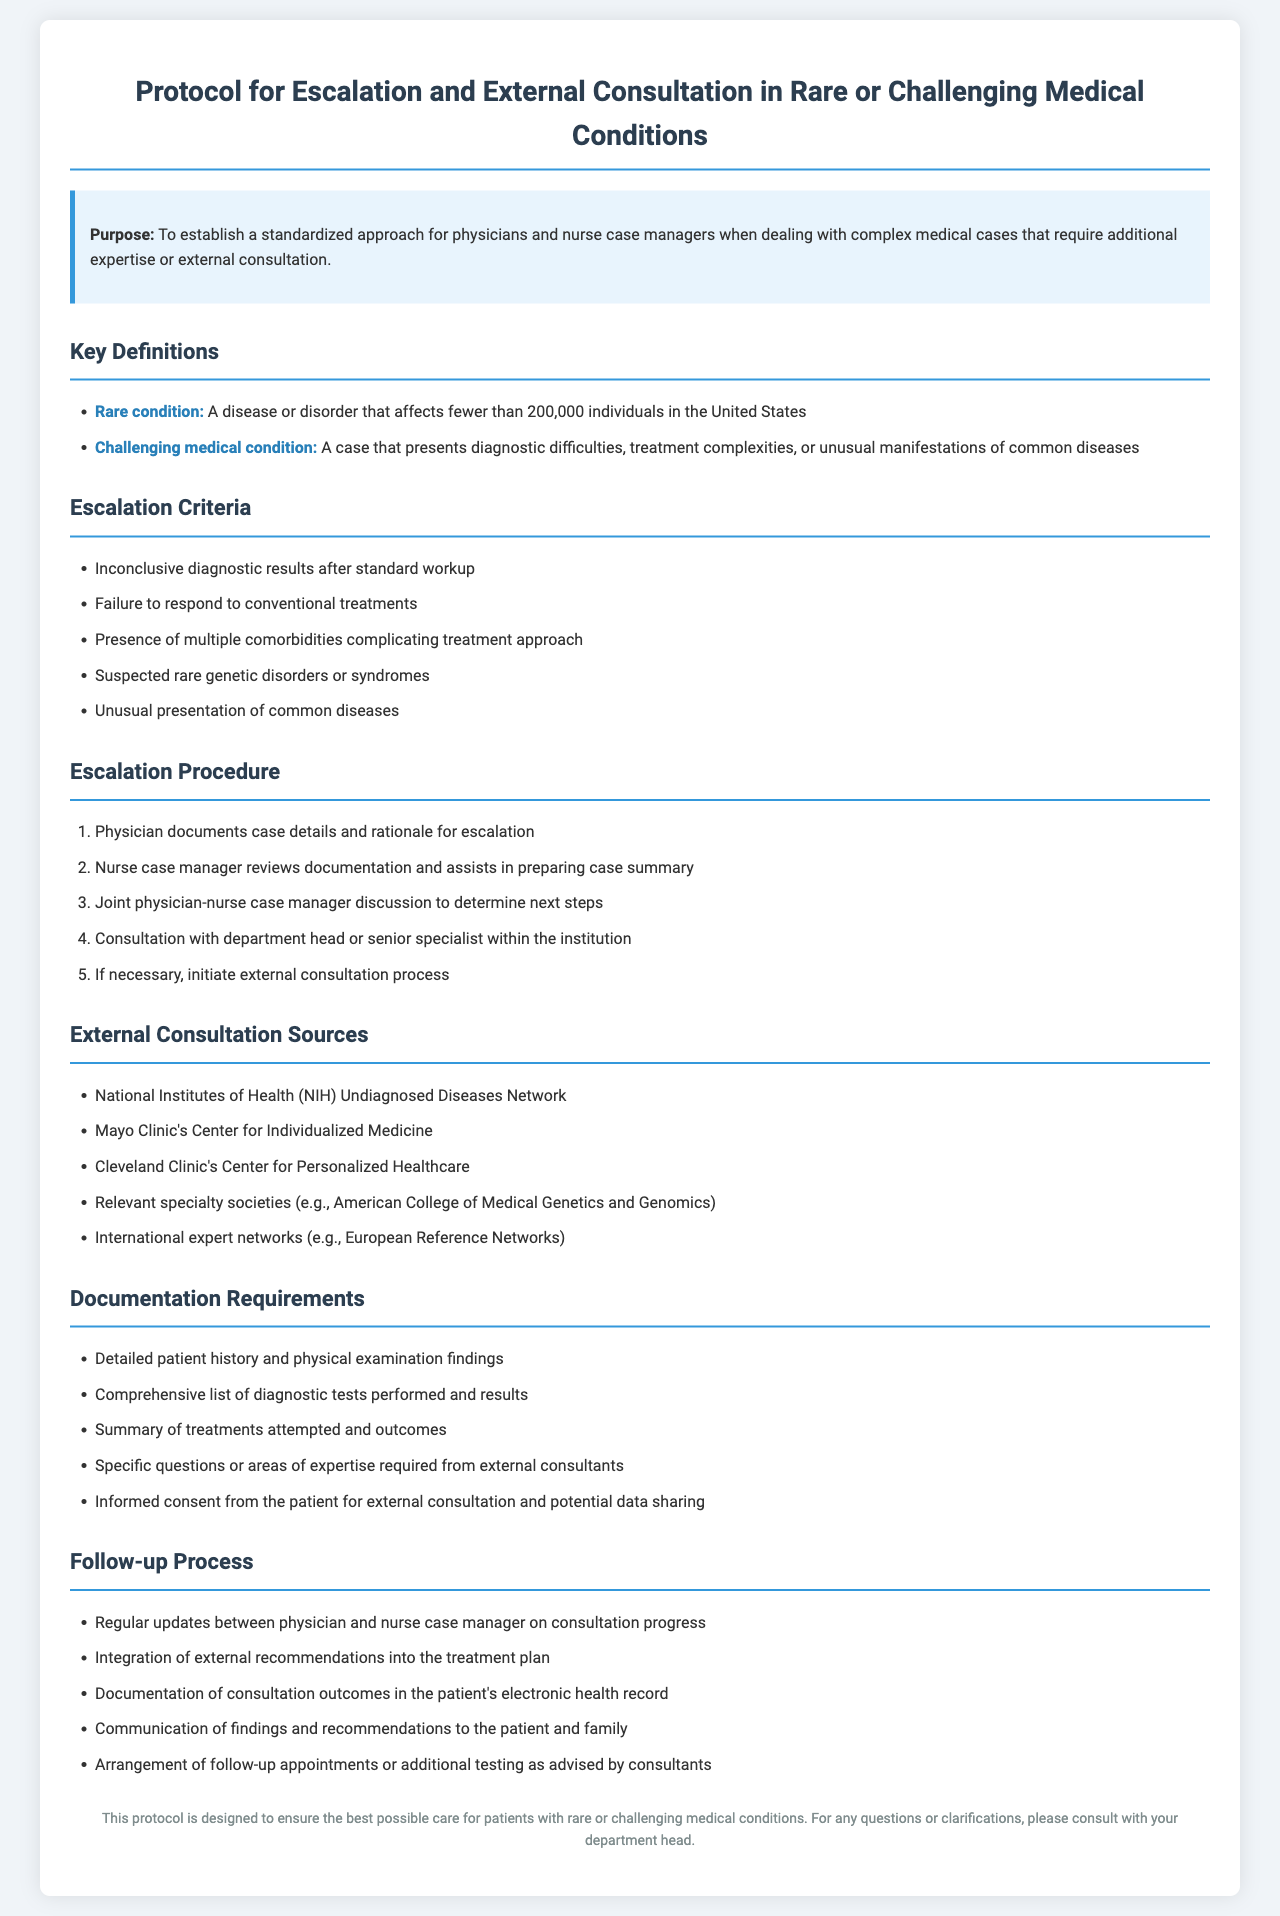What is the purpose of the protocol? The purpose of the protocol is to establish a standardized approach for physicians and nurse case managers when dealing with complex medical cases that require additional expertise or external consultation.
Answer: To establish a standardized approach What constitutes a rare condition? A rare condition is defined as a disease or disorder that affects fewer than 200,000 individuals in the United States.
Answer: A disease or disorder that affects fewer than 200,000 individuals What is the first escalation criterion? The first escalation criterion listed is inconclusive diagnostic results after standard workup.
Answer: Inconclusive diagnostic results after standard workup How many steps are in the escalation procedure? There are five steps in the escalation procedure as outlined in the document.
Answer: Five steps Name one external consultation source mentioned. The document lists the National Institutes of Health (NIH) Undiagnosed Diseases Network as one external consultation source.
Answer: National Institutes of Health (NIH) Undiagnosed Diseases Network What is required for informed consent in the documentation process? Informed consent from the patient for external consultation and potential data sharing is required.
Answer: Informed consent from the patient What should be included in the follow-up process? Regular updates between physician and nurse case manager on consultation progress should be included in the follow-up process.
Answer: Regular updates between physician and nurse case manager Which professionals collaborate according to the protocol? Physicians and nurse case managers are specified as the professionals who collaborate according to the protocol.
Answer: Physicians and nurse case managers 